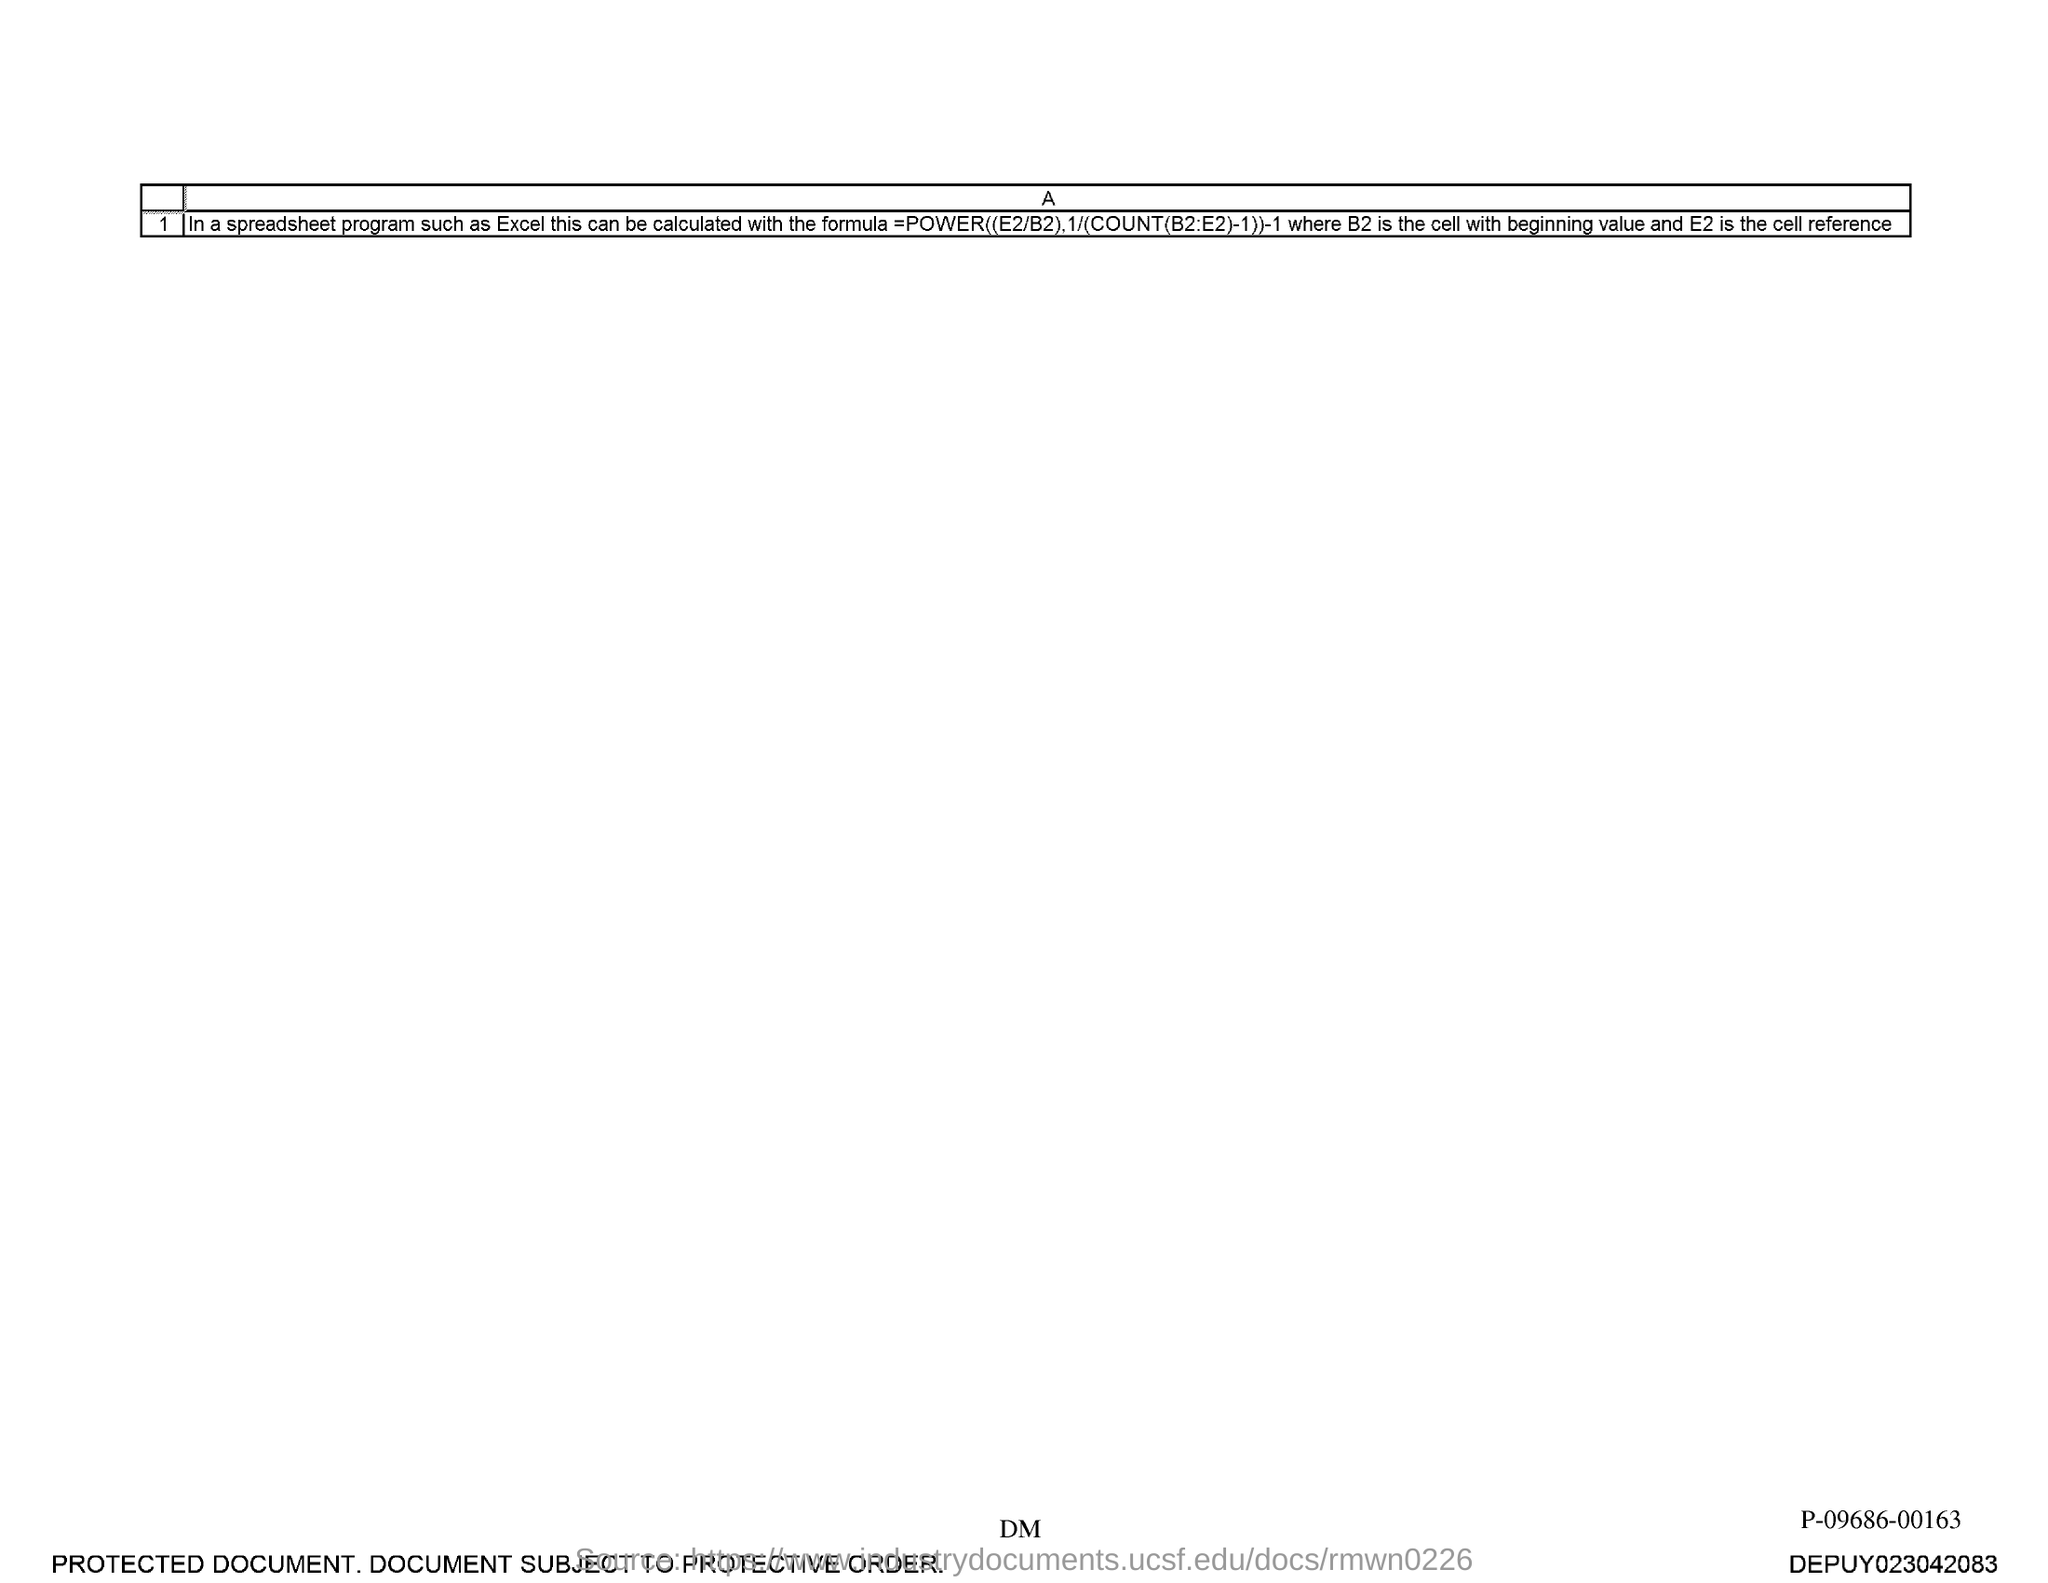In this document E2 is called?
Provide a short and direct response. Cell reference. 